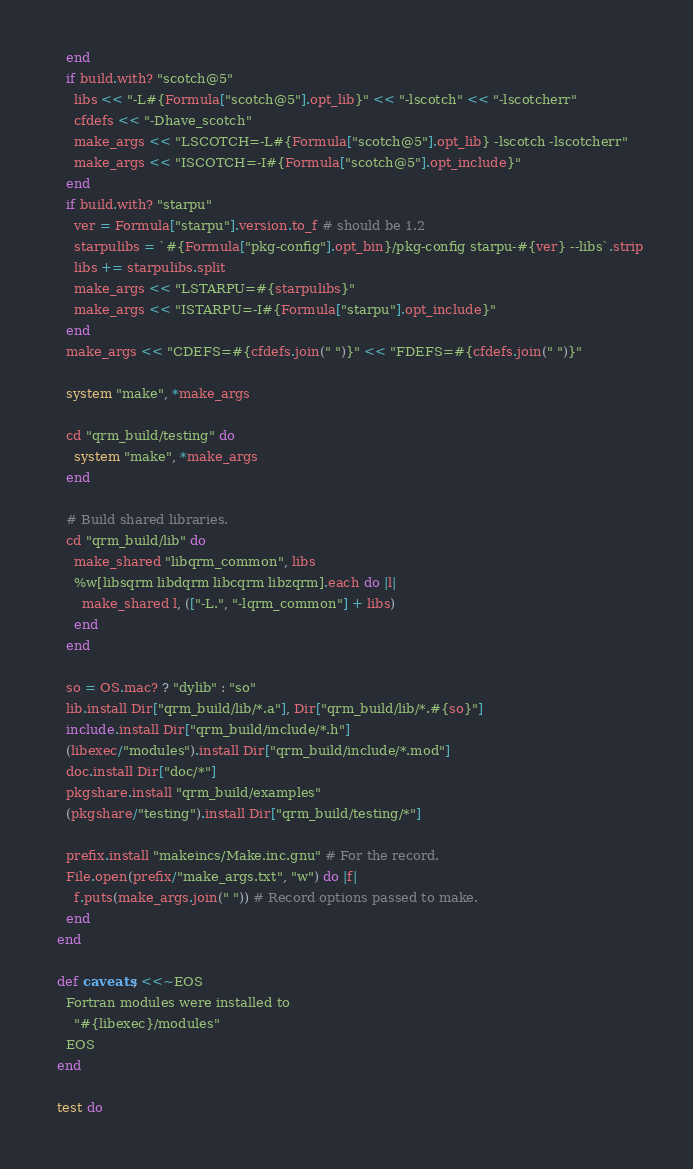Convert code to text. <code><loc_0><loc_0><loc_500><loc_500><_Ruby_>    end
    if build.with? "scotch@5"
      libs << "-L#{Formula["scotch@5"].opt_lib}" << "-lscotch" << "-lscotcherr"
      cfdefs << "-Dhave_scotch"
      make_args << "LSCOTCH=-L#{Formula["scotch@5"].opt_lib} -lscotch -lscotcherr"
      make_args << "ISCOTCH=-I#{Formula["scotch@5"].opt_include}"
    end
    if build.with? "starpu"
      ver = Formula["starpu"].version.to_f # should be 1.2
      starpulibs = `#{Formula["pkg-config"].opt_bin}/pkg-config starpu-#{ver} --libs`.strip
      libs += starpulibs.split
      make_args << "LSTARPU=#{starpulibs}"
      make_args << "ISTARPU=-I#{Formula["starpu"].opt_include}"
    end
    make_args << "CDEFS=#{cfdefs.join(" ")}" << "FDEFS=#{cfdefs.join(" ")}"

    system "make", *make_args

    cd "qrm_build/testing" do
      system "make", *make_args
    end

    # Build shared libraries.
    cd "qrm_build/lib" do
      make_shared "libqrm_common", libs
      %w[libsqrm libdqrm libcqrm libzqrm].each do |l|
        make_shared l, (["-L.", "-lqrm_common"] + libs)
      end
    end

    so = OS.mac? ? "dylib" : "so"
    lib.install Dir["qrm_build/lib/*.a"], Dir["qrm_build/lib/*.#{so}"]
    include.install Dir["qrm_build/include/*.h"]
    (libexec/"modules").install Dir["qrm_build/include/*.mod"]
    doc.install Dir["doc/*"]
    pkgshare.install "qrm_build/examples"
    (pkgshare/"testing").install Dir["qrm_build/testing/*"]

    prefix.install "makeincs/Make.inc.gnu" # For the record.
    File.open(prefix/"make_args.txt", "w") do |f|
      f.puts(make_args.join(" ")) # Record options passed to make.
    end
  end

  def caveats; <<~EOS
    Fortran modules were installed to
      "#{libexec}/modules"
    EOS
  end

  test do</code> 